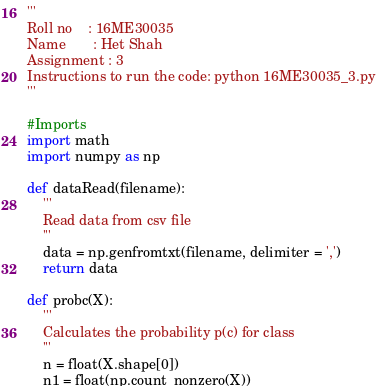Convert code to text. <code><loc_0><loc_0><loc_500><loc_500><_Python_>'''
Roll no    : 16ME30035	
Name       : Het Shah
Assignment : 3
Instructions to run the code: python 16ME30035_3.py
'''

#Imports
import math
import numpy as np

def dataRead(filename):
	'''
	Read data from csv file
	'''
	data = np.genfromtxt(filename, delimiter = ',')	
	return data 

def probc(X):
	'''
	Calculates the probability p(c) for class
	'''
	n = float(X.shape[0])
	n1 = float(np.count_nonzero(X))</code> 